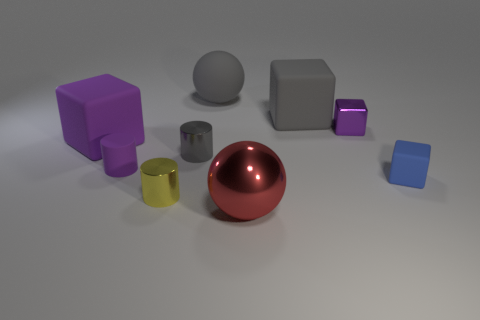Subtract all metal cylinders. How many cylinders are left? 1 Subtract 2 cubes. How many cubes are left? 2 Subtract all yellow cylinders. How many cylinders are left? 2 Subtract 0 red cylinders. How many objects are left? 9 Subtract all cylinders. How many objects are left? 6 Subtract all gray spheres. Subtract all cyan blocks. How many spheres are left? 1 Subtract all red cylinders. How many blue cubes are left? 1 Subtract all tiny blue rubber blocks. Subtract all large purple matte cylinders. How many objects are left? 8 Add 5 small purple metallic objects. How many small purple metallic objects are left? 6 Add 8 big matte spheres. How many big matte spheres exist? 9 